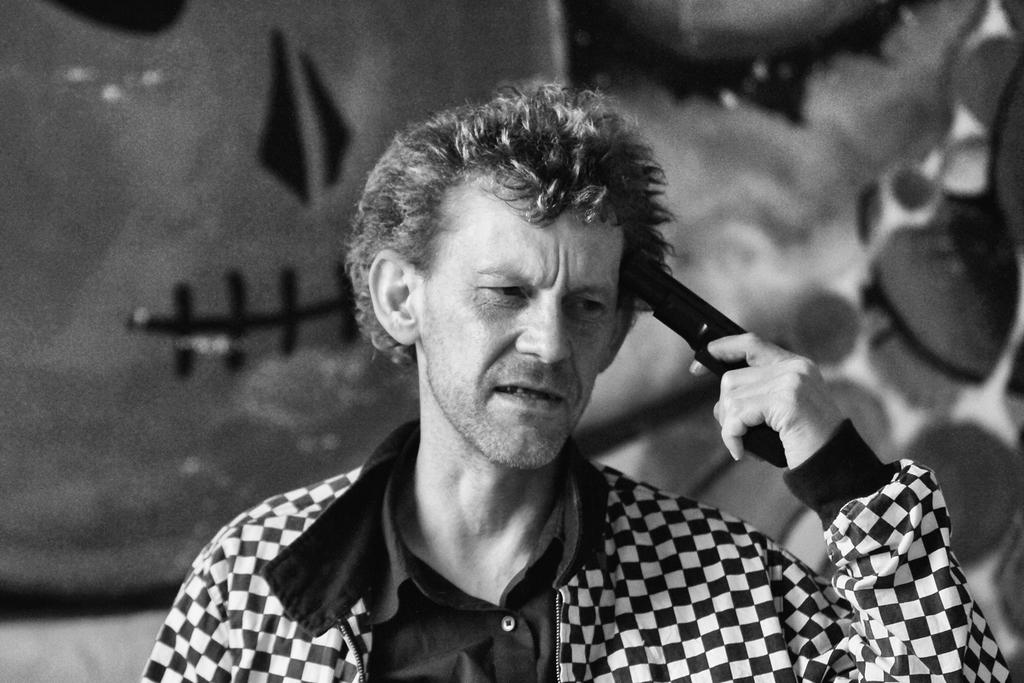What is the main subject in the foreground of the image? There is a man standing in the foreground of the image. What is the man wearing? The man is wearing a coat. What is the man holding in the image? The man is holding a gun. Can you describe the background of the image? The background of the image is not clear. What is the name of the manager in the image? There is no manager present in the image, as the main subject is a man holding a gun. What type of street can be seen in the image? There is no street visible in the image; the background is not clear. 